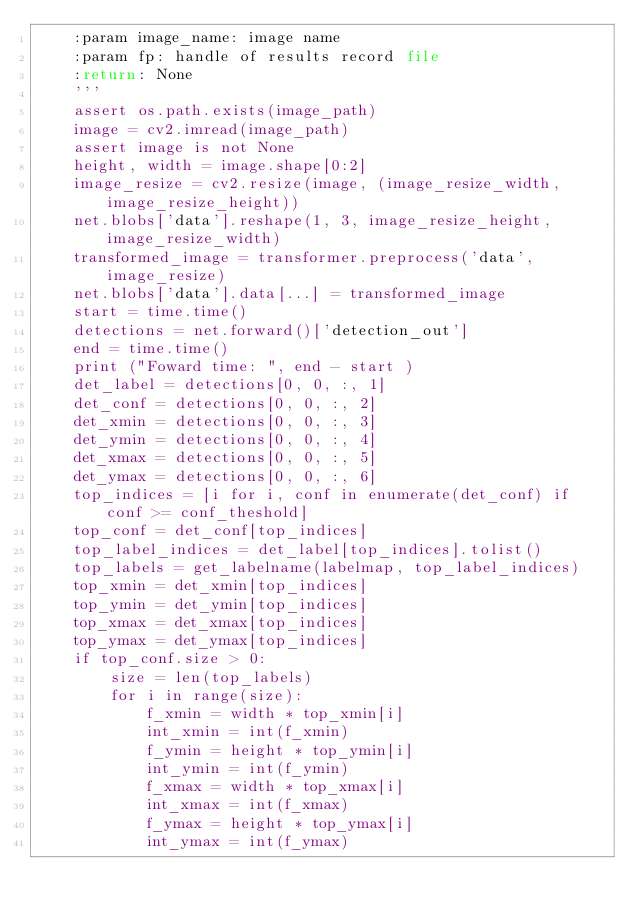Convert code to text. <code><loc_0><loc_0><loc_500><loc_500><_Python_>    :param image_name: image name
    :param fp: handle of results record file
    :return: None
    '''
    assert os.path.exists(image_path)
    image = cv2.imread(image_path)
    assert image is not None
    height, width = image.shape[0:2]
    image_resize = cv2.resize(image, (image_resize_width, image_resize_height))
    net.blobs['data'].reshape(1, 3, image_resize_height, image_resize_width)
    transformed_image = transformer.preprocess('data', image_resize)
    net.blobs['data'].data[...] = transformed_image
    start = time.time()
    detections = net.forward()['detection_out']
    end = time.time()
    print ("Foward time: ", end - start )
    det_label = detections[0, 0, :, 1]
    det_conf = detections[0, 0, :, 2]
    det_xmin = detections[0, 0, :, 3]
    det_ymin = detections[0, 0, :, 4]
    det_xmax = detections[0, 0, :, 5]
    det_ymax = detections[0, 0, :, 6]
    top_indices = [i for i, conf in enumerate(det_conf) if conf >= conf_theshold]
    top_conf = det_conf[top_indices]
    top_label_indices = det_label[top_indices].tolist()
    top_labels = get_labelname(labelmap, top_label_indices)
    top_xmin = det_xmin[top_indices]
    top_ymin = det_ymin[top_indices]
    top_xmax = det_xmax[top_indices]
    top_ymax = det_ymax[top_indices]
    if top_conf.size > 0:    
        size = len(top_labels)
        for i in range(size):
            f_xmin = width * top_xmin[i]
            int_xmin = int(f_xmin)
            f_ymin = height * top_ymin[i]
            int_ymin = int(f_ymin)
            f_xmax = width * top_xmax[i]
            int_xmax = int(f_xmax)
            f_ymax = height * top_ymax[i]
            int_ymax = int(f_ymax)</code> 